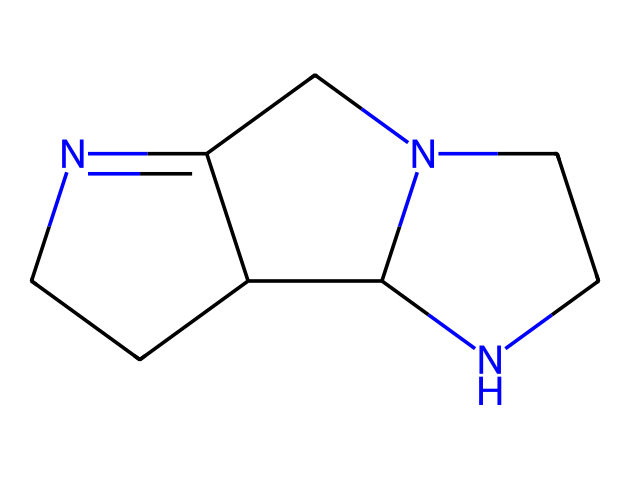What is the total number of nitrogen atoms in this compound? The SMILES representation contains three nitrogen atoms, which can be counted directly from the structure.
Answer: 3 What type of ring system does 1,5,7-triazabicyclo[4.4.0]dec-5-ene feature? The "bicyclo" indicates a bicyclic structure, and the "[4.4.0]" signifies that it contains two 4-membered rings.
Answer: bicyclic What is the primary functional group present in this compound? An examination of the structure reveals that it contains guanidine-like characteristics due to the presence of nitrogen and carbon in a specific arrangement, identifying it as a superbase.
Answer: guanidine Which atom connects the two rings in the bicyclic structure? The connection of the two rings in the bicyclic structure shows the presence of a carbon atom that acts as a bridge between the two rings.
Answer: carbon What is the degree of unsaturation in this compound? To determine the degree of unsaturation, we can analyze the number of rings and double bonds present; since it has two rings and no additional double bonds, the degree of unsaturation is approximately calculated as the number of rings plus one for each double bond, which indicates that it is a complex structure.
Answer: 4 How many carbon atoms are present in this molecular structure? By analyzing the structure, we can count a total of seven carbon atoms, each represented in the SMILES.
Answer: 7 